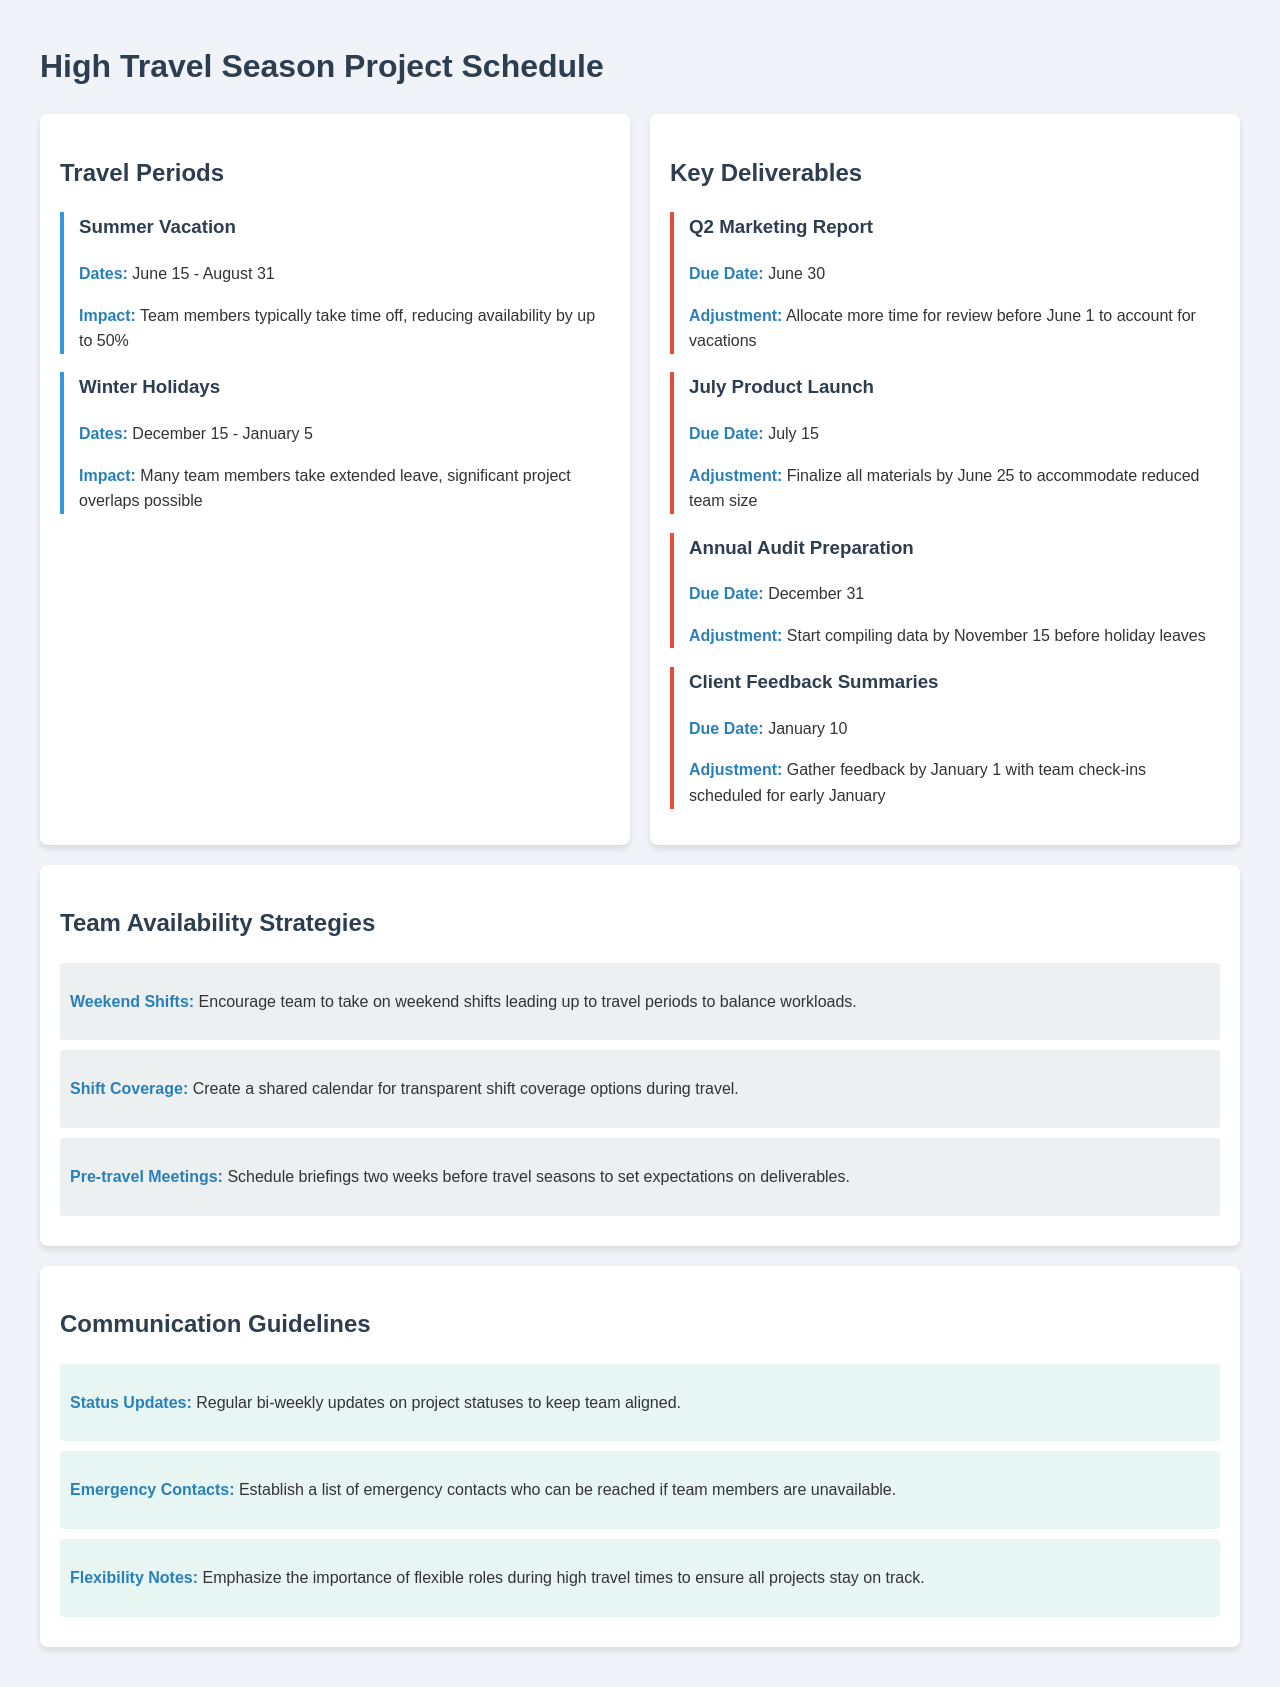What are the dates of the Summer Vacation? The Summer Vacation period is defined in the document with specific dates mentioned.
Answer: June 15 - August 31 What is the impact of Winter Holidays on team availability? The impact indicates how team availability is affected during the Winter Holidays.
Answer: Significant project overlaps possible When is the due date for the Q2 Marketing Report? The due date for the Q2 Marketing Report is stated directly in the document.
Answer: June 30 What adjustments are suggested for the July Product Launch? The document provides specific adjustments needed for the July Product Launch.
Answer: Finalize all materials by June 25 When should data compilation for the Annual Audit Preparation start? The document mentions a specific date to start compiling the data for the Annual Audit Preparation.
Answer: November 15 How many team members are expected to be absent by the end of the Summer Vacation? The document quantifies the expected team member absence during the Summer Vacation period.
Answer: Up to 50% What strategy encourages taking on weekend shifts? The document outlines specific strategies for managing workloads during busy periods.
Answer: Weekend Shifts How often are status updates recommended? The frequency of status updates is explicitly mentioned in the communication guidelines.
Answer: Bi-weekly What type of document is this? The overall context and structure of the document provide insight into its type.
Answer: Schedule 